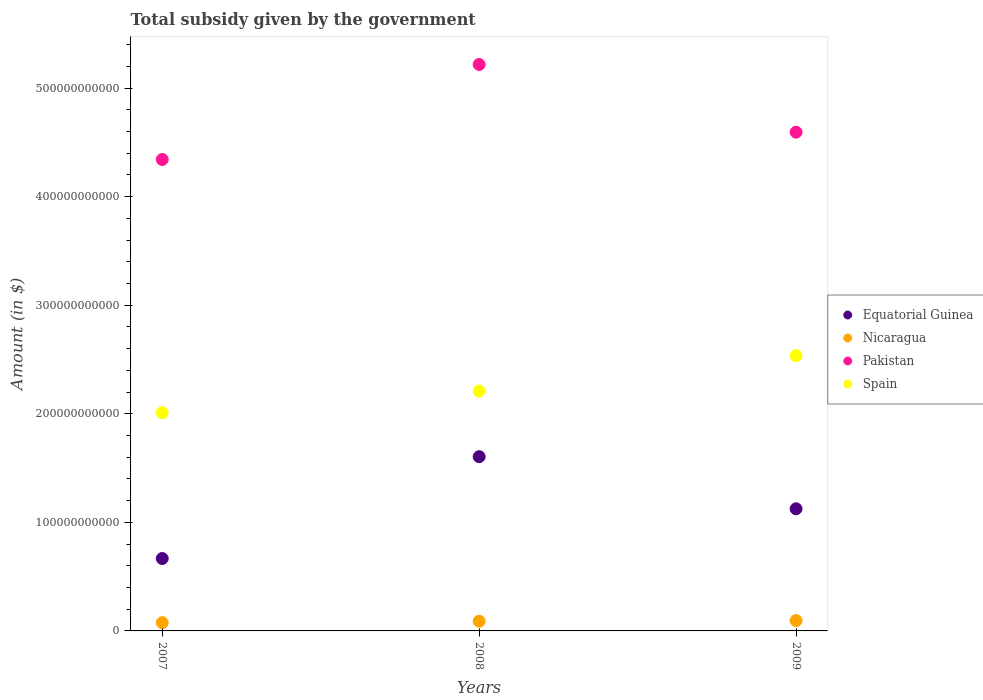How many different coloured dotlines are there?
Your answer should be compact. 4. Is the number of dotlines equal to the number of legend labels?
Your answer should be very brief. Yes. What is the total revenue collected by the government in Spain in 2009?
Your answer should be compact. 2.54e+11. Across all years, what is the maximum total revenue collected by the government in Equatorial Guinea?
Keep it short and to the point. 1.60e+11. Across all years, what is the minimum total revenue collected by the government in Equatorial Guinea?
Your answer should be compact. 6.67e+1. In which year was the total revenue collected by the government in Spain minimum?
Offer a very short reply. 2007. What is the total total revenue collected by the government in Equatorial Guinea in the graph?
Your answer should be very brief. 3.40e+11. What is the difference between the total revenue collected by the government in Equatorial Guinea in 2007 and that in 2008?
Keep it short and to the point. -9.38e+1. What is the difference between the total revenue collected by the government in Nicaragua in 2009 and the total revenue collected by the government in Pakistan in 2007?
Offer a very short reply. -4.25e+11. What is the average total revenue collected by the government in Spain per year?
Ensure brevity in your answer.  2.25e+11. In the year 2008, what is the difference between the total revenue collected by the government in Spain and total revenue collected by the government in Nicaragua?
Give a very brief answer. 2.12e+11. What is the ratio of the total revenue collected by the government in Spain in 2007 to that in 2009?
Your answer should be very brief. 0.79. Is the difference between the total revenue collected by the government in Spain in 2007 and 2008 greater than the difference between the total revenue collected by the government in Nicaragua in 2007 and 2008?
Offer a terse response. No. What is the difference between the highest and the second highest total revenue collected by the government in Pakistan?
Your answer should be compact. 6.23e+1. What is the difference between the highest and the lowest total revenue collected by the government in Nicaragua?
Your answer should be compact. 1.93e+09. In how many years, is the total revenue collected by the government in Nicaragua greater than the average total revenue collected by the government in Nicaragua taken over all years?
Keep it short and to the point. 2. Does the total revenue collected by the government in Equatorial Guinea monotonically increase over the years?
Provide a short and direct response. No. Is the total revenue collected by the government in Equatorial Guinea strictly greater than the total revenue collected by the government in Spain over the years?
Give a very brief answer. No. Is the total revenue collected by the government in Nicaragua strictly less than the total revenue collected by the government in Equatorial Guinea over the years?
Offer a very short reply. Yes. What is the difference between two consecutive major ticks on the Y-axis?
Provide a short and direct response. 1.00e+11. Does the graph contain grids?
Offer a terse response. No. How are the legend labels stacked?
Your response must be concise. Vertical. What is the title of the graph?
Offer a terse response. Total subsidy given by the government. Does "Japan" appear as one of the legend labels in the graph?
Keep it short and to the point. No. What is the label or title of the X-axis?
Keep it short and to the point. Years. What is the label or title of the Y-axis?
Keep it short and to the point. Amount (in $). What is the Amount (in $) of Equatorial Guinea in 2007?
Your answer should be compact. 6.67e+1. What is the Amount (in $) in Nicaragua in 2007?
Give a very brief answer. 7.60e+09. What is the Amount (in $) in Pakistan in 2007?
Keep it short and to the point. 4.34e+11. What is the Amount (in $) of Spain in 2007?
Provide a succinct answer. 2.01e+11. What is the Amount (in $) of Equatorial Guinea in 2008?
Offer a terse response. 1.60e+11. What is the Amount (in $) in Nicaragua in 2008?
Offer a terse response. 8.93e+09. What is the Amount (in $) of Pakistan in 2008?
Your answer should be compact. 5.22e+11. What is the Amount (in $) of Spain in 2008?
Offer a terse response. 2.21e+11. What is the Amount (in $) of Equatorial Guinea in 2009?
Keep it short and to the point. 1.12e+11. What is the Amount (in $) in Nicaragua in 2009?
Provide a short and direct response. 9.54e+09. What is the Amount (in $) in Pakistan in 2009?
Your answer should be compact. 4.59e+11. What is the Amount (in $) of Spain in 2009?
Ensure brevity in your answer.  2.54e+11. Across all years, what is the maximum Amount (in $) of Equatorial Guinea?
Offer a very short reply. 1.60e+11. Across all years, what is the maximum Amount (in $) of Nicaragua?
Your response must be concise. 9.54e+09. Across all years, what is the maximum Amount (in $) in Pakistan?
Your answer should be very brief. 5.22e+11. Across all years, what is the maximum Amount (in $) of Spain?
Give a very brief answer. 2.54e+11. Across all years, what is the minimum Amount (in $) in Equatorial Guinea?
Make the answer very short. 6.67e+1. Across all years, what is the minimum Amount (in $) of Nicaragua?
Make the answer very short. 7.60e+09. Across all years, what is the minimum Amount (in $) in Pakistan?
Offer a very short reply. 4.34e+11. Across all years, what is the minimum Amount (in $) of Spain?
Offer a terse response. 2.01e+11. What is the total Amount (in $) in Equatorial Guinea in the graph?
Your answer should be compact. 3.40e+11. What is the total Amount (in $) in Nicaragua in the graph?
Provide a short and direct response. 2.61e+1. What is the total Amount (in $) in Pakistan in the graph?
Give a very brief answer. 1.42e+12. What is the total Amount (in $) of Spain in the graph?
Make the answer very short. 6.76e+11. What is the difference between the Amount (in $) of Equatorial Guinea in 2007 and that in 2008?
Your answer should be compact. -9.38e+1. What is the difference between the Amount (in $) of Nicaragua in 2007 and that in 2008?
Your response must be concise. -1.33e+09. What is the difference between the Amount (in $) in Pakistan in 2007 and that in 2008?
Ensure brevity in your answer.  -8.75e+1. What is the difference between the Amount (in $) of Spain in 2007 and that in 2008?
Make the answer very short. -1.99e+1. What is the difference between the Amount (in $) of Equatorial Guinea in 2007 and that in 2009?
Make the answer very short. -4.58e+1. What is the difference between the Amount (in $) of Nicaragua in 2007 and that in 2009?
Offer a terse response. -1.93e+09. What is the difference between the Amount (in $) of Pakistan in 2007 and that in 2009?
Ensure brevity in your answer.  -2.52e+1. What is the difference between the Amount (in $) of Spain in 2007 and that in 2009?
Offer a terse response. -5.25e+1. What is the difference between the Amount (in $) in Equatorial Guinea in 2008 and that in 2009?
Keep it short and to the point. 4.80e+1. What is the difference between the Amount (in $) in Nicaragua in 2008 and that in 2009?
Your answer should be compact. -6.05e+08. What is the difference between the Amount (in $) in Pakistan in 2008 and that in 2009?
Provide a succinct answer. 6.23e+1. What is the difference between the Amount (in $) in Spain in 2008 and that in 2009?
Ensure brevity in your answer.  -3.26e+1. What is the difference between the Amount (in $) in Equatorial Guinea in 2007 and the Amount (in $) in Nicaragua in 2008?
Offer a terse response. 5.78e+1. What is the difference between the Amount (in $) in Equatorial Guinea in 2007 and the Amount (in $) in Pakistan in 2008?
Your answer should be compact. -4.55e+11. What is the difference between the Amount (in $) in Equatorial Guinea in 2007 and the Amount (in $) in Spain in 2008?
Provide a succinct answer. -1.54e+11. What is the difference between the Amount (in $) in Nicaragua in 2007 and the Amount (in $) in Pakistan in 2008?
Your answer should be very brief. -5.14e+11. What is the difference between the Amount (in $) of Nicaragua in 2007 and the Amount (in $) of Spain in 2008?
Ensure brevity in your answer.  -2.13e+11. What is the difference between the Amount (in $) of Pakistan in 2007 and the Amount (in $) of Spain in 2008?
Provide a short and direct response. 2.13e+11. What is the difference between the Amount (in $) of Equatorial Guinea in 2007 and the Amount (in $) of Nicaragua in 2009?
Offer a terse response. 5.72e+1. What is the difference between the Amount (in $) of Equatorial Guinea in 2007 and the Amount (in $) of Pakistan in 2009?
Provide a succinct answer. -3.93e+11. What is the difference between the Amount (in $) of Equatorial Guinea in 2007 and the Amount (in $) of Spain in 2009?
Make the answer very short. -1.87e+11. What is the difference between the Amount (in $) of Nicaragua in 2007 and the Amount (in $) of Pakistan in 2009?
Provide a short and direct response. -4.52e+11. What is the difference between the Amount (in $) of Nicaragua in 2007 and the Amount (in $) of Spain in 2009?
Offer a terse response. -2.46e+11. What is the difference between the Amount (in $) in Pakistan in 2007 and the Amount (in $) in Spain in 2009?
Keep it short and to the point. 1.81e+11. What is the difference between the Amount (in $) in Equatorial Guinea in 2008 and the Amount (in $) in Nicaragua in 2009?
Provide a short and direct response. 1.51e+11. What is the difference between the Amount (in $) in Equatorial Guinea in 2008 and the Amount (in $) in Pakistan in 2009?
Offer a very short reply. -2.99e+11. What is the difference between the Amount (in $) in Equatorial Guinea in 2008 and the Amount (in $) in Spain in 2009?
Keep it short and to the point. -9.31e+1. What is the difference between the Amount (in $) in Nicaragua in 2008 and the Amount (in $) in Pakistan in 2009?
Provide a succinct answer. -4.50e+11. What is the difference between the Amount (in $) of Nicaragua in 2008 and the Amount (in $) of Spain in 2009?
Keep it short and to the point. -2.45e+11. What is the difference between the Amount (in $) in Pakistan in 2008 and the Amount (in $) in Spain in 2009?
Your response must be concise. 2.68e+11. What is the average Amount (in $) of Equatorial Guinea per year?
Your answer should be very brief. 1.13e+11. What is the average Amount (in $) in Nicaragua per year?
Provide a short and direct response. 8.69e+09. What is the average Amount (in $) of Pakistan per year?
Your answer should be compact. 4.72e+11. What is the average Amount (in $) in Spain per year?
Your answer should be very brief. 2.25e+11. In the year 2007, what is the difference between the Amount (in $) of Equatorial Guinea and Amount (in $) of Nicaragua?
Keep it short and to the point. 5.91e+1. In the year 2007, what is the difference between the Amount (in $) of Equatorial Guinea and Amount (in $) of Pakistan?
Ensure brevity in your answer.  -3.68e+11. In the year 2007, what is the difference between the Amount (in $) in Equatorial Guinea and Amount (in $) in Spain?
Your response must be concise. -1.34e+11. In the year 2007, what is the difference between the Amount (in $) in Nicaragua and Amount (in $) in Pakistan?
Your answer should be very brief. -4.27e+11. In the year 2007, what is the difference between the Amount (in $) in Nicaragua and Amount (in $) in Spain?
Your answer should be compact. -1.93e+11. In the year 2007, what is the difference between the Amount (in $) in Pakistan and Amount (in $) in Spain?
Your answer should be very brief. 2.33e+11. In the year 2008, what is the difference between the Amount (in $) of Equatorial Guinea and Amount (in $) of Nicaragua?
Provide a short and direct response. 1.52e+11. In the year 2008, what is the difference between the Amount (in $) of Equatorial Guinea and Amount (in $) of Pakistan?
Offer a terse response. -3.61e+11. In the year 2008, what is the difference between the Amount (in $) of Equatorial Guinea and Amount (in $) of Spain?
Keep it short and to the point. -6.05e+1. In the year 2008, what is the difference between the Amount (in $) of Nicaragua and Amount (in $) of Pakistan?
Make the answer very short. -5.13e+11. In the year 2008, what is the difference between the Amount (in $) of Nicaragua and Amount (in $) of Spain?
Give a very brief answer. -2.12e+11. In the year 2008, what is the difference between the Amount (in $) of Pakistan and Amount (in $) of Spain?
Make the answer very short. 3.01e+11. In the year 2009, what is the difference between the Amount (in $) in Equatorial Guinea and Amount (in $) in Nicaragua?
Your answer should be very brief. 1.03e+11. In the year 2009, what is the difference between the Amount (in $) in Equatorial Guinea and Amount (in $) in Pakistan?
Make the answer very short. -3.47e+11. In the year 2009, what is the difference between the Amount (in $) of Equatorial Guinea and Amount (in $) of Spain?
Give a very brief answer. -1.41e+11. In the year 2009, what is the difference between the Amount (in $) of Nicaragua and Amount (in $) of Pakistan?
Ensure brevity in your answer.  -4.50e+11. In the year 2009, what is the difference between the Amount (in $) in Nicaragua and Amount (in $) in Spain?
Your answer should be very brief. -2.44e+11. In the year 2009, what is the difference between the Amount (in $) of Pakistan and Amount (in $) of Spain?
Your response must be concise. 2.06e+11. What is the ratio of the Amount (in $) in Equatorial Guinea in 2007 to that in 2008?
Offer a terse response. 0.42. What is the ratio of the Amount (in $) in Nicaragua in 2007 to that in 2008?
Give a very brief answer. 0.85. What is the ratio of the Amount (in $) of Pakistan in 2007 to that in 2008?
Offer a terse response. 0.83. What is the ratio of the Amount (in $) of Spain in 2007 to that in 2008?
Your response must be concise. 0.91. What is the ratio of the Amount (in $) of Equatorial Guinea in 2007 to that in 2009?
Provide a succinct answer. 0.59. What is the ratio of the Amount (in $) of Nicaragua in 2007 to that in 2009?
Offer a terse response. 0.8. What is the ratio of the Amount (in $) of Pakistan in 2007 to that in 2009?
Provide a short and direct response. 0.95. What is the ratio of the Amount (in $) of Spain in 2007 to that in 2009?
Your answer should be compact. 0.79. What is the ratio of the Amount (in $) of Equatorial Guinea in 2008 to that in 2009?
Give a very brief answer. 1.43. What is the ratio of the Amount (in $) in Nicaragua in 2008 to that in 2009?
Your answer should be very brief. 0.94. What is the ratio of the Amount (in $) in Pakistan in 2008 to that in 2009?
Ensure brevity in your answer.  1.14. What is the ratio of the Amount (in $) of Spain in 2008 to that in 2009?
Give a very brief answer. 0.87. What is the difference between the highest and the second highest Amount (in $) in Equatorial Guinea?
Offer a terse response. 4.80e+1. What is the difference between the highest and the second highest Amount (in $) of Nicaragua?
Your answer should be very brief. 6.05e+08. What is the difference between the highest and the second highest Amount (in $) of Pakistan?
Provide a short and direct response. 6.23e+1. What is the difference between the highest and the second highest Amount (in $) in Spain?
Provide a succinct answer. 3.26e+1. What is the difference between the highest and the lowest Amount (in $) in Equatorial Guinea?
Provide a succinct answer. 9.38e+1. What is the difference between the highest and the lowest Amount (in $) in Nicaragua?
Make the answer very short. 1.93e+09. What is the difference between the highest and the lowest Amount (in $) of Pakistan?
Provide a succinct answer. 8.75e+1. What is the difference between the highest and the lowest Amount (in $) in Spain?
Your answer should be very brief. 5.25e+1. 